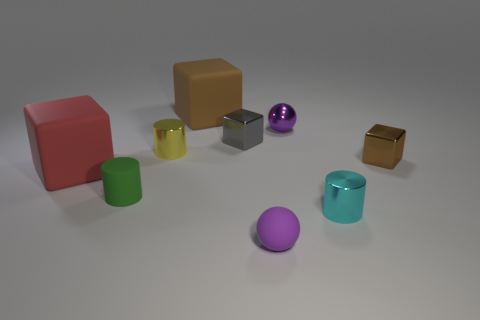Can you tell me the colors of the spherical objects in the image? Certainly! In the image, there are two spherical objects. One is purple, and the other is a shiny metallic purple. 